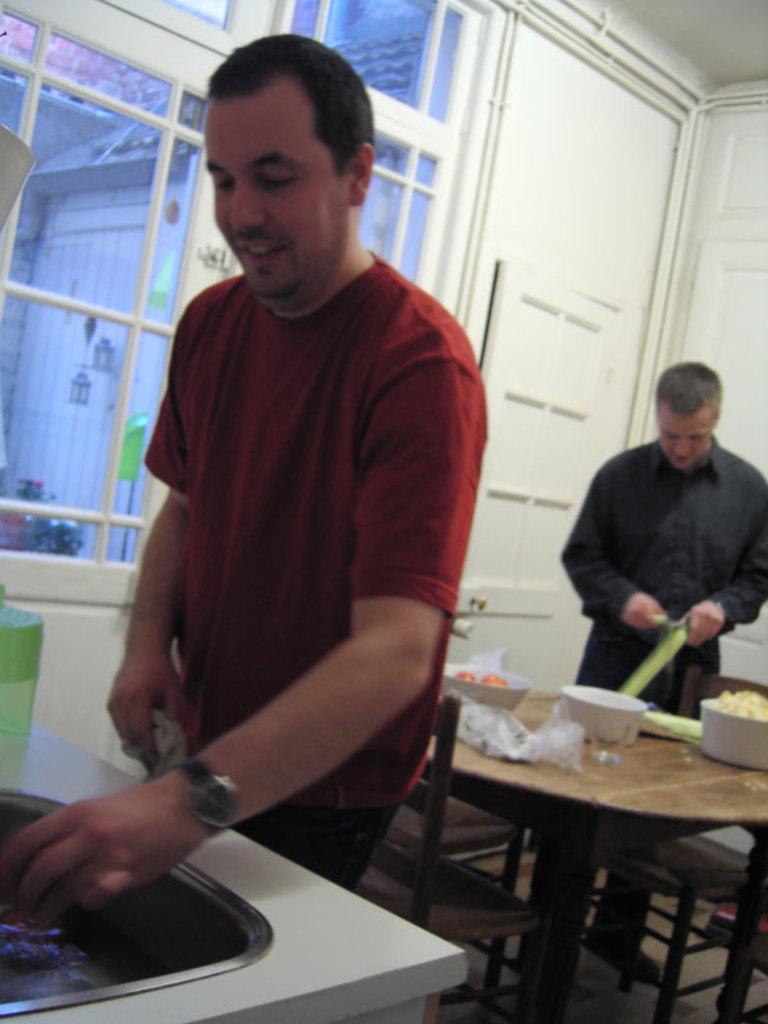Please provide a concise description of this image. This image is clicked inside the house. There are two men in this image. In the front, the man is wearing red t-shirt and smiling. To the right, the man is wearing black dress and cutting vegetables. In the middle, there is a dining table along with chairs. In the background, there is a door, window. 